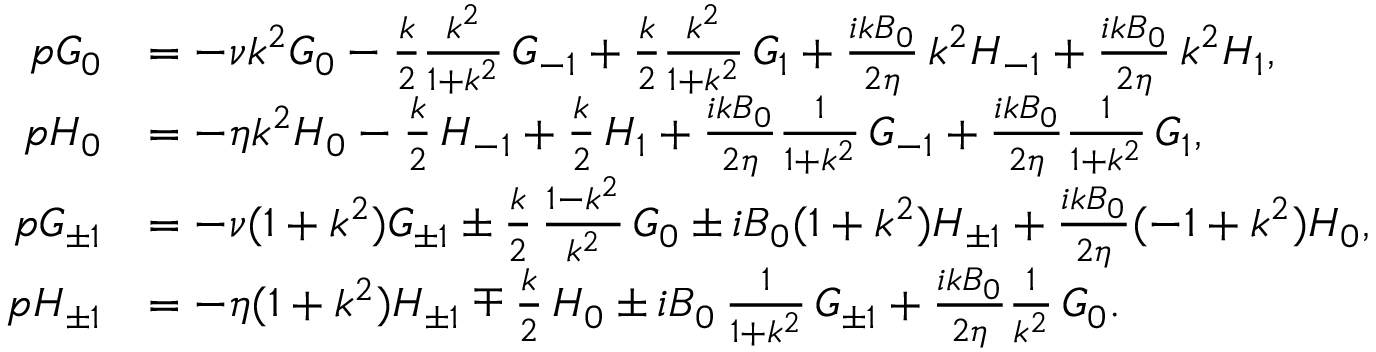<formula> <loc_0><loc_0><loc_500><loc_500>\begin{array} { r l } { p G _ { 0 } } & { = - \nu k ^ { 2 } G _ { 0 } - \frac { k } { 2 } \frac { k ^ { 2 } } { 1 + k ^ { 2 } } \, G _ { - 1 } + \frac { k } { 2 } \frac { k ^ { 2 } } { 1 + k ^ { 2 } } \, G _ { 1 } + \frac { i k B _ { 0 } } { 2 \eta } \, k ^ { 2 } H _ { - 1 } + \frac { i k B _ { 0 } } { 2 \eta } \, k ^ { 2 } H _ { 1 } , } \\ { p H _ { 0 } } & { = - \eta k ^ { 2 } H _ { 0 } - \frac { k } { 2 } \, H _ { - 1 } + \frac { k } { 2 } \, H _ { 1 } + \frac { i k B _ { 0 } } { 2 \eta } \frac { 1 } { 1 + k ^ { 2 } } \, G _ { - 1 } + \frac { i k B _ { 0 } } { 2 \eta } \frac { 1 } { 1 + k ^ { 2 } } \, G _ { 1 } , } \\ { p G _ { \pm 1 } } & { = - \nu ( 1 + k ^ { 2 } ) G _ { \pm 1 } \pm \frac { k } { 2 } \, \frac { 1 - k ^ { 2 } } { k ^ { 2 } } \, G _ { 0 } \pm i B _ { 0 } ( 1 + k ^ { 2 } ) H _ { \pm 1 } + \frac { i k B _ { 0 } } { 2 \eta } ( - 1 + k ^ { 2 } ) H _ { 0 } , } \\ { p H _ { \pm 1 } } & { = - \eta ( 1 + k ^ { 2 } ) H _ { \pm 1 } \mp \frac { k } { 2 } \, H _ { 0 } \pm i B _ { 0 } \, \frac { 1 } { 1 + k ^ { 2 } } \, G _ { \pm 1 } + \frac { i k B _ { 0 } } { 2 \eta } \frac { 1 } { k ^ { 2 } } \, G _ { 0 } . } \end{array}</formula> 